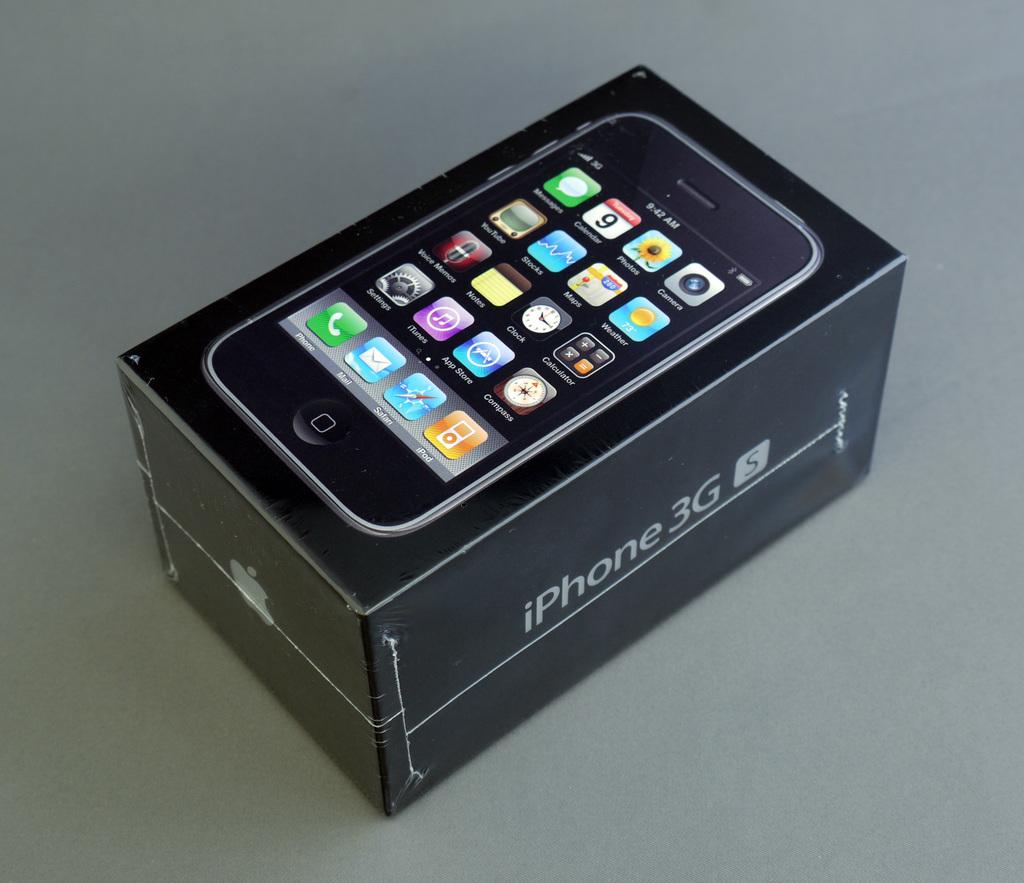What g is the phone here?
Offer a very short reply. 3g. 